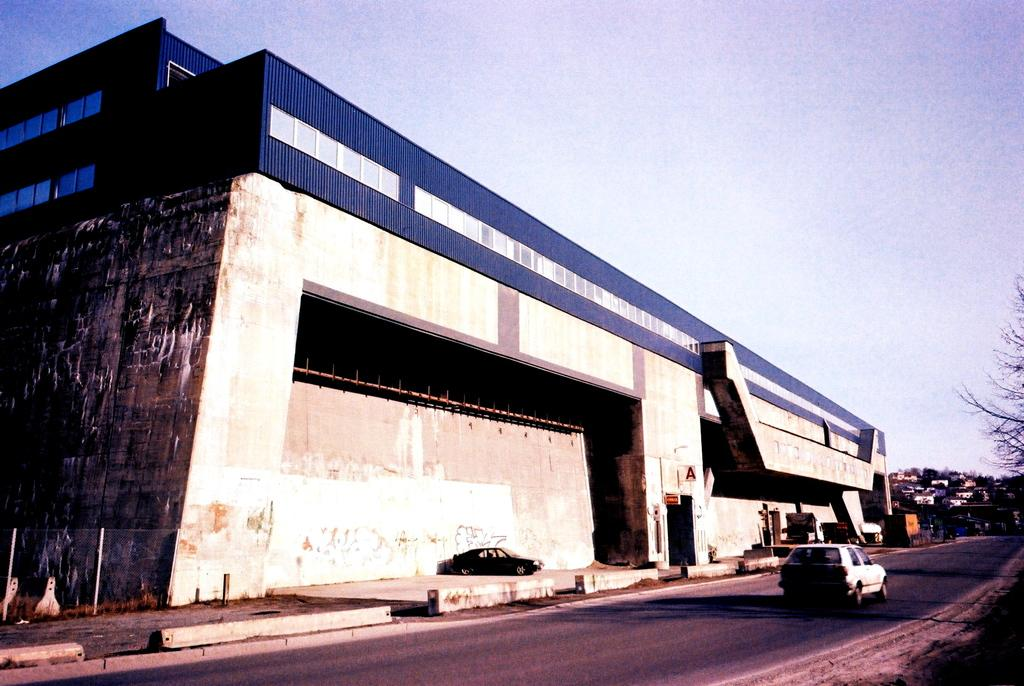What is the main subject of the image? There is a car on the road in the image. What else can be seen in the image besides the car? There are buildings, trees, and the sky visible in the image. How many girls are playing with the worm in the image? There are no girls or worms present in the image. 